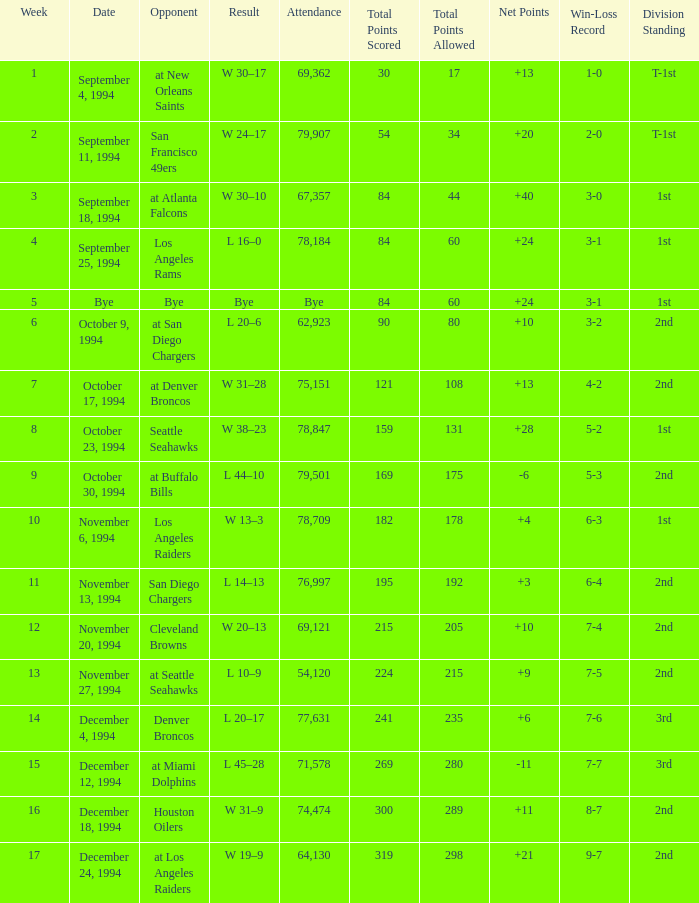What was the score of the Chiefs November 27, 1994 game? L 10–9. Parse the full table. {'header': ['Week', 'Date', 'Opponent', 'Result', 'Attendance', 'Total Points Scored', 'Total Points Allowed', 'Net Points', 'Win-Loss Record', 'Division Standing'], 'rows': [['1', 'September 4, 1994', 'at New Orleans Saints', 'W 30–17', '69,362', '30', '17', '+13', '1-0', 'T-1st'], ['2', 'September 11, 1994', 'San Francisco 49ers', 'W 24–17', '79,907', '54', '34', '+20', '2-0', 'T-1st'], ['3', 'September 18, 1994', 'at Atlanta Falcons', 'W 30–10', '67,357', '84', '44', '+40', '3-0', '1st'], ['4', 'September 25, 1994', 'Los Angeles Rams', 'L 16–0', '78,184', '84', '60', '+24', '3-1', '1st'], ['5', 'Bye', 'Bye', 'Bye', 'Bye', '84', '60', '+24', '3-1', '1st'], ['6', 'October 9, 1994', 'at San Diego Chargers', 'L 20–6', '62,923', '90', '80', '+10', '3-2', '2nd'], ['7', 'October 17, 1994', 'at Denver Broncos', 'W 31–28', '75,151', '121', '108', '+13', '4-2', '2nd'], ['8', 'October 23, 1994', 'Seattle Seahawks', 'W 38–23', '78,847', '159', '131', '+28', '5-2', '1st'], ['9', 'October 30, 1994', 'at Buffalo Bills', 'L 44–10', '79,501', '169', '175', '-6', '5-3', '2nd'], ['10', 'November 6, 1994', 'Los Angeles Raiders', 'W 13–3', '78,709', '182', '178', '+4', '6-3', '1st'], ['11', 'November 13, 1994', 'San Diego Chargers', 'L 14–13', '76,997', '195', '192', '+3', '6-4', '2nd'], ['12', 'November 20, 1994', 'Cleveland Browns', 'W 20–13', '69,121', '215', '205', '+10', '7-4', '2nd'], ['13', 'November 27, 1994', 'at Seattle Seahawks', 'L 10–9', '54,120', '224', '215', '+9', '7-5', '2nd'], ['14', 'December 4, 1994', 'Denver Broncos', 'L 20–17', '77,631', '241', '235', '+6', '7-6', '3rd'], ['15', 'December 12, 1994', 'at Miami Dolphins', 'L 45–28', '71,578', '269', '280', '-11', '7-7', '3rd'], ['16', 'December 18, 1994', 'Houston Oilers', 'W 31–9', '74,474', '300', '289', '+11', '8-7', '2nd'], ['17', 'December 24, 1994', 'at Los Angeles Raiders', 'W 19–9', '64,130', '319', '298', '+21', '9-7', '2nd']]} 